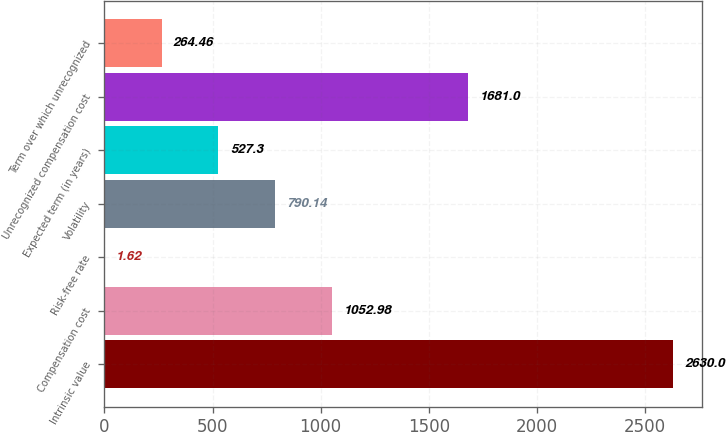Convert chart. <chart><loc_0><loc_0><loc_500><loc_500><bar_chart><fcel>Intrinsic value<fcel>Compensation cost<fcel>Risk-free rate<fcel>Volatility<fcel>Expected term (in years)<fcel>Unrecognized compensation cost<fcel>Term over which unrecognized<nl><fcel>2630<fcel>1052.98<fcel>1.62<fcel>790.14<fcel>527.3<fcel>1681<fcel>264.46<nl></chart> 